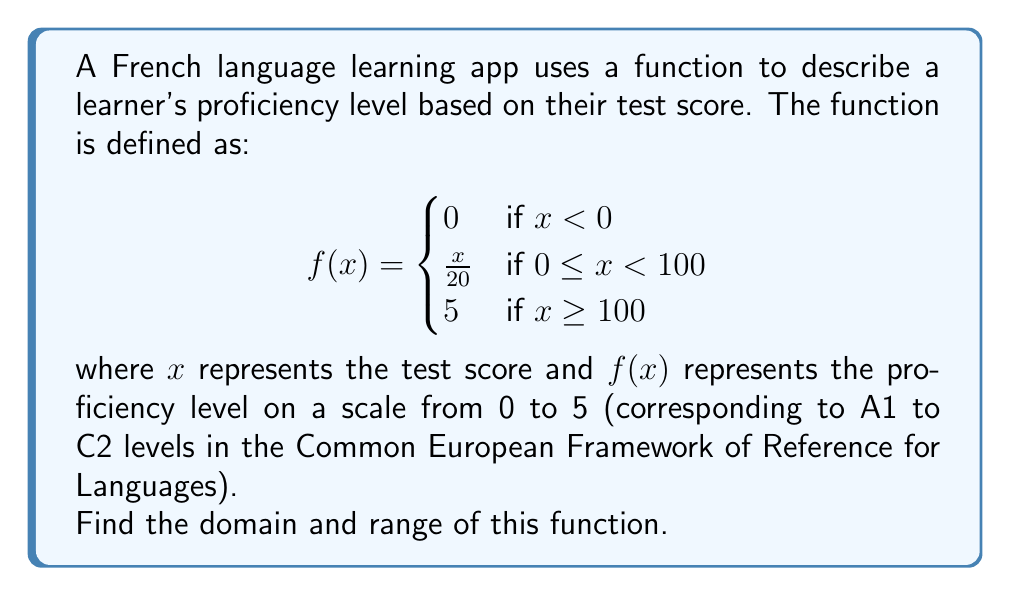Provide a solution to this math problem. To find the domain and range of this piecewise function, we need to analyze each piece separately:

1. Domain:
   The function is defined for all real numbers, as it covers all possible cases:
   - For $x < 0$, $f(x) = 0$
   - For $0 \leq x < 100$, $f(x) = \frac{x}{20}$
   - For $x \geq 100$, $f(x) = 5$
   
   Therefore, the domain is all real numbers: $(-\infty, \infty)$

2. Range:
   Let's examine the possible output values for each piece:
   - When $x < 0$, $f(x) = 0$
   - When $0 \leq x < 100$, $f(x) = \frac{x}{20}$:
     The minimum value is $\frac{0}{20} = 0$ (when $x = 0$)
     The maximum value approaches but never reaches $\frac{100}{20} = 5$
   - When $x \geq 100$, $f(x) = 5$

   Combining these results, we see that the function can output any value from 0 to 5, including 0 and 5.
   
   Therefore, the range is $[0, 5]$.
Answer: Domain: $(-\infty, \infty)$
Range: $[0, 5]$ 